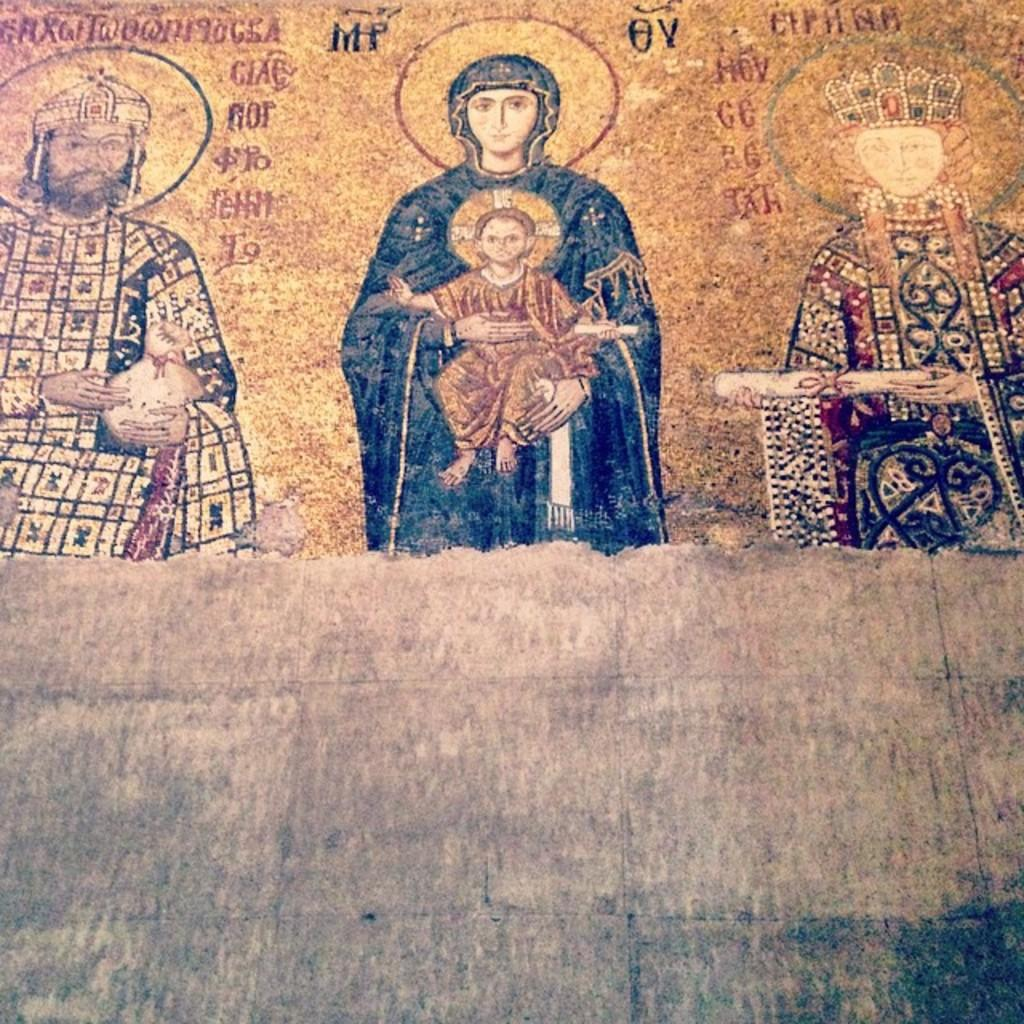What is depicted in the painting in the image? There is a painting of a few persons in the image. What else can be seen on the wall in the image? There is text on the wall in the image. What type of spark can be seen coming from the tray in the image? There is no tray present in the image, so there cannot be any spark coming from it. 